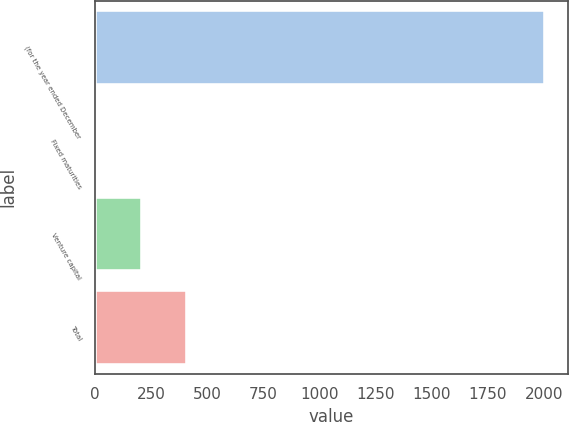Convert chart to OTSL. <chart><loc_0><loc_0><loc_500><loc_500><bar_chart><fcel>(for the year ended December<fcel>Fixed maturities<fcel>Venture capital<fcel>Total<nl><fcel>2006<fcel>7<fcel>206.9<fcel>406.8<nl></chart> 